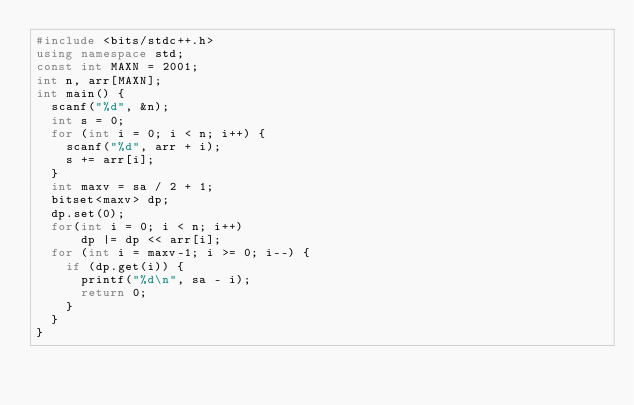Convert code to text. <code><loc_0><loc_0><loc_500><loc_500><_C++_>#include <bits/stdc++.h>
using namespace std;
const int MAXN = 2001;
int n, arr[MAXN];
int main() {
	scanf("%d", &n);
	int s = 0;
	for (int i = 0; i < n; i++) {
		scanf("%d", arr + i);
		s += arr[i];
	}
	int maxv = sa / 2 + 1;
	bitset<maxv> dp;
	dp.set(0);
	for(int i = 0; i < n; i++)
	    dp |= dp << arr[i];
	for (int i = maxv-1; i >= 0; i--) {
		if (dp.get(i)) {
			printf("%d\n", sa - i);
			return 0;
		}
	}
}</code> 